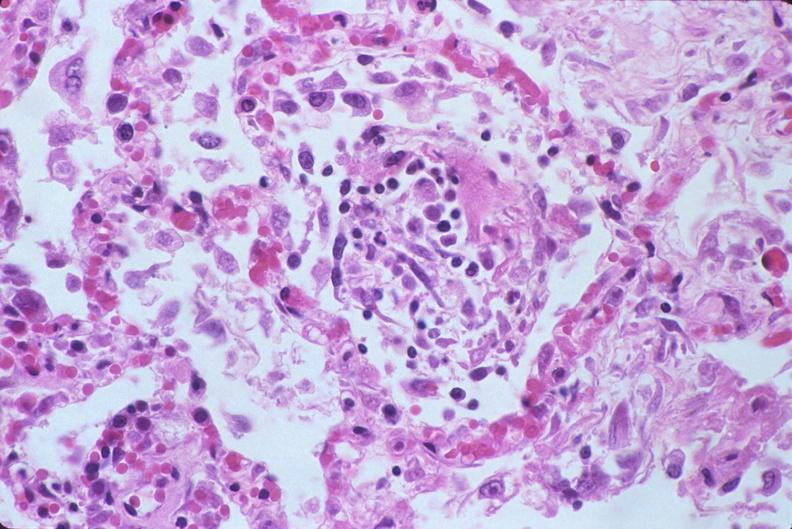what does this image show?
Answer the question using a single word or phrase. Lung 